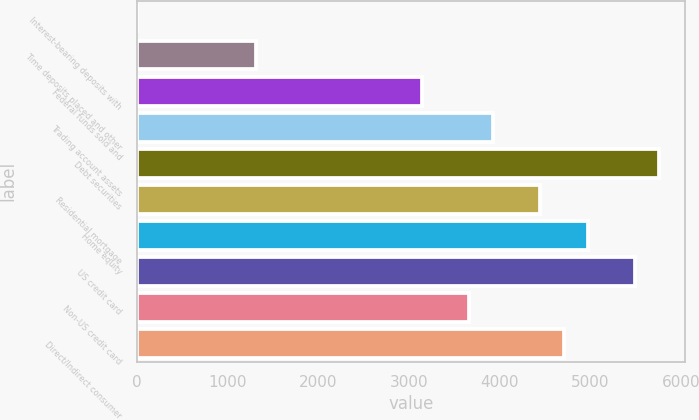Convert chart. <chart><loc_0><loc_0><loc_500><loc_500><bar_chart><fcel>Interest-bearing deposits with<fcel>Time deposits placed and other<fcel>Federal funds sold and<fcel>Trading account assets<fcel>Debt securities<fcel>Residential mortgage<fcel>Home equity<fcel>US credit card<fcel>Non-US credit card<fcel>Direct/Indirect consumer<nl><fcel>8<fcel>1314.5<fcel>3143.6<fcel>3927.5<fcel>5756.6<fcel>4450.1<fcel>4972.7<fcel>5495.3<fcel>3666.2<fcel>4711.4<nl></chart> 